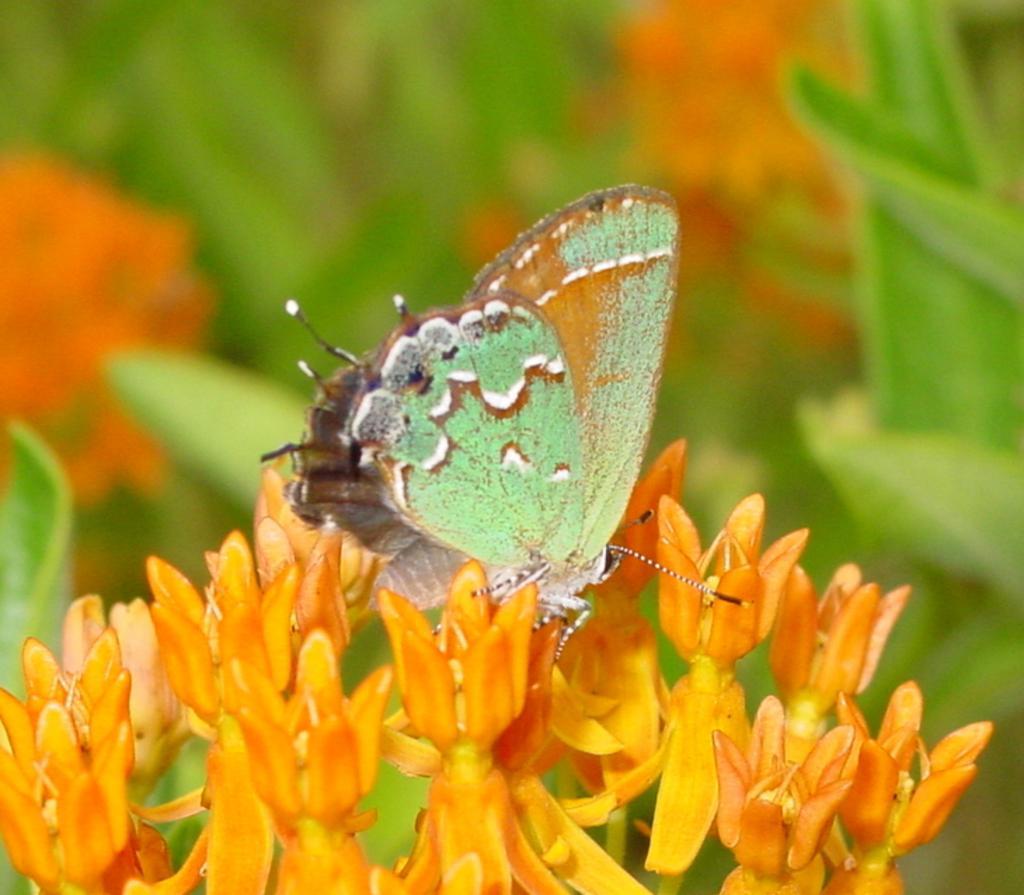How would you summarize this image in a sentence or two? In this picture we can see a butterfly on the flowers and we can see blurry background. 